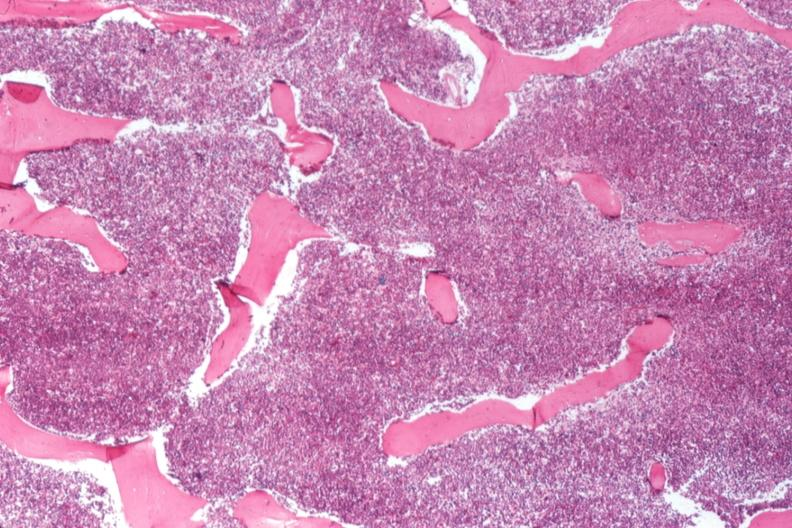what does this image show?
Answer the question using a single word or phrase. 100 % cellular marrow 